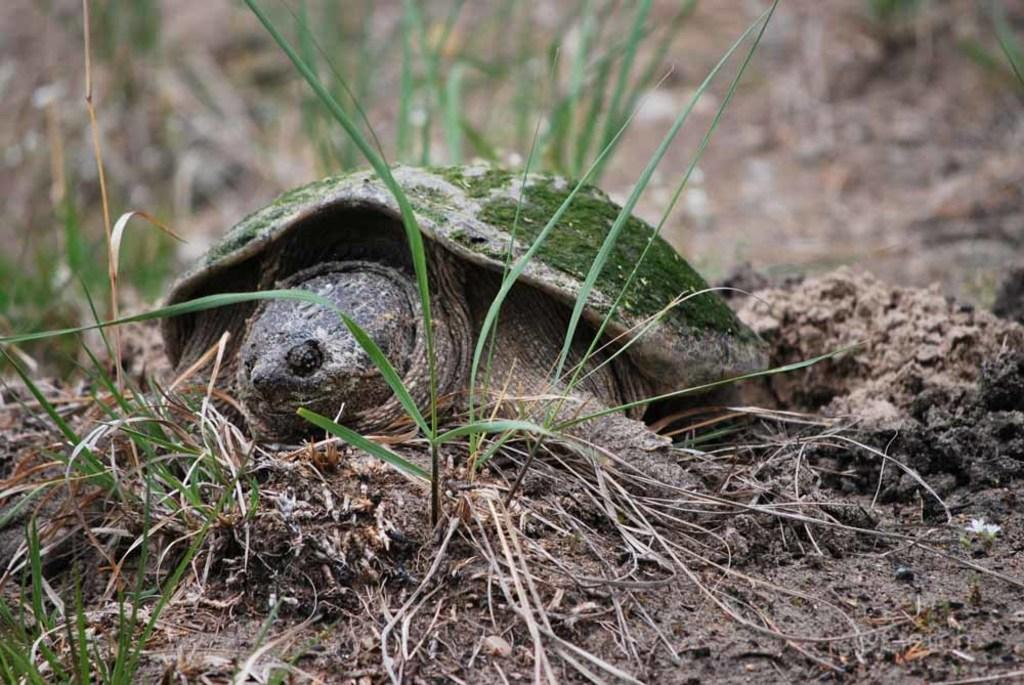What animal is present in the image? There is a turtle in the image. What colors can be seen on the turtle? The turtle has black, cream, brown, and green colors. Where is the turtle located in the image? The turtle is on the ground. What type of vegetation is visible in the image? There is grass visible in the image. How would you describe the background of the image? The background of the image is blurry. What type of house can be seen in the background of the image? There is no house present in the image; the background is blurry. How does the turtle lead the other animals in the image? There are no other animals present in the image, and the turtle is not shown leading any animals. 